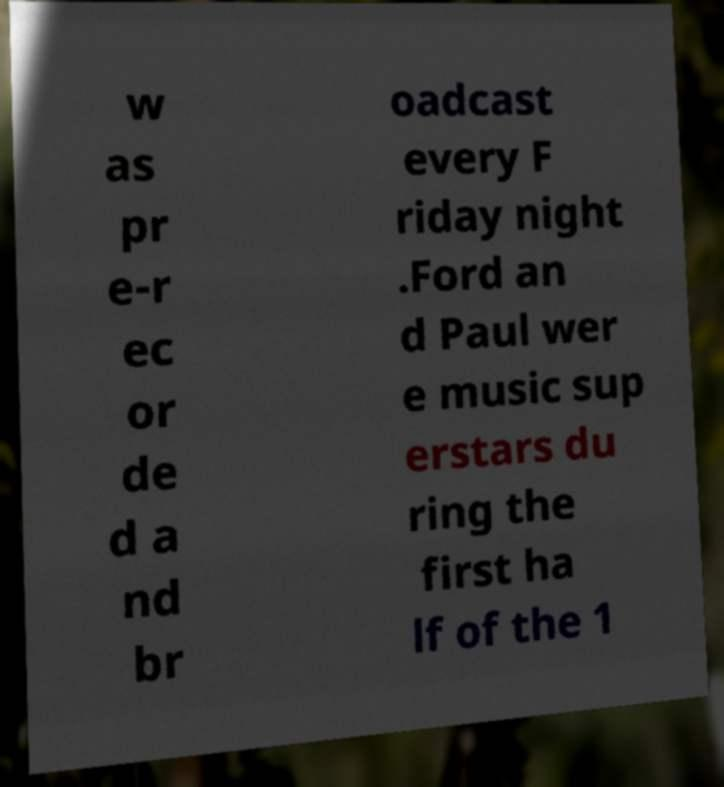There's text embedded in this image that I need extracted. Can you transcribe it verbatim? w as pr e-r ec or de d a nd br oadcast every F riday night .Ford an d Paul wer e music sup erstars du ring the first ha lf of the 1 